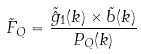<formula> <loc_0><loc_0><loc_500><loc_500>\tilde { F } _ { Q } = \frac { \tilde { \hat { g } } _ { 1 } ( k ) \times \tilde { b } ( k ) } { P _ { Q } ( k ) }</formula> 